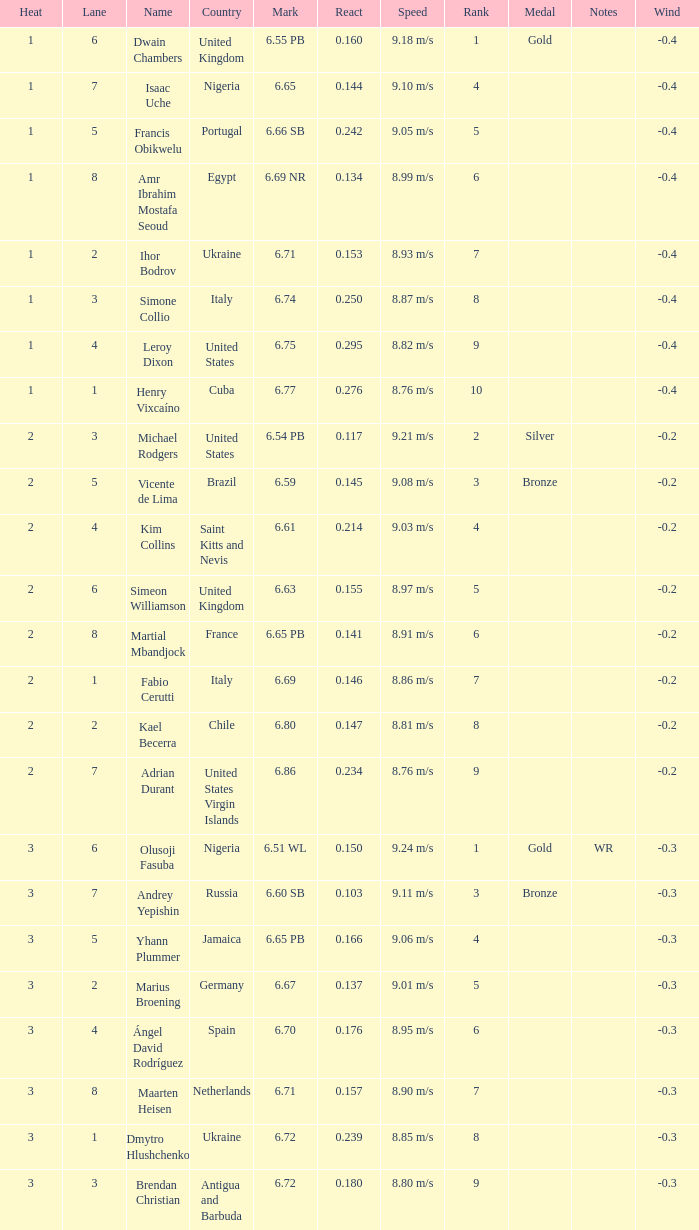166? Portugal. 